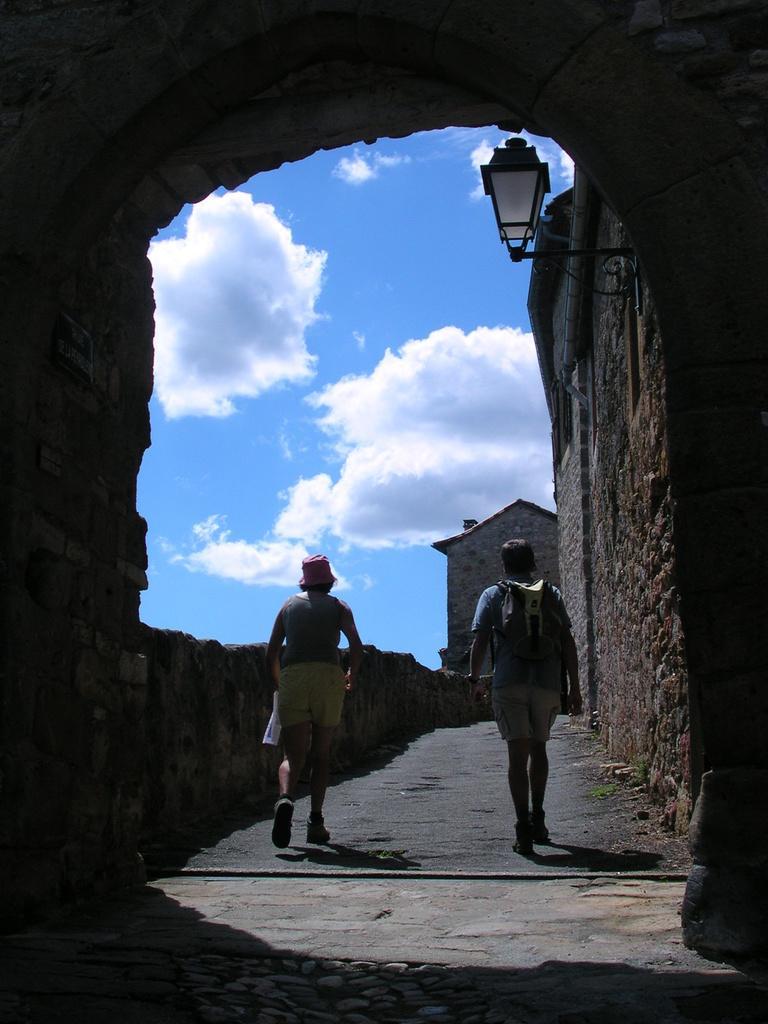Could you give a brief overview of what you see in this image? In this image, we can see people walking on the bridge and one of them is wearing a cap and holding a paper and the other is wearing a bag. In the background, there is a wall and we can see a light and there are clouds in the sky. 